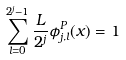<formula> <loc_0><loc_0><loc_500><loc_500>\sum _ { l = 0 } ^ { 2 ^ { j } - 1 } \frac { L } { 2 ^ { j } } \phi ^ { P } _ { j , l } ( x ) = 1</formula> 